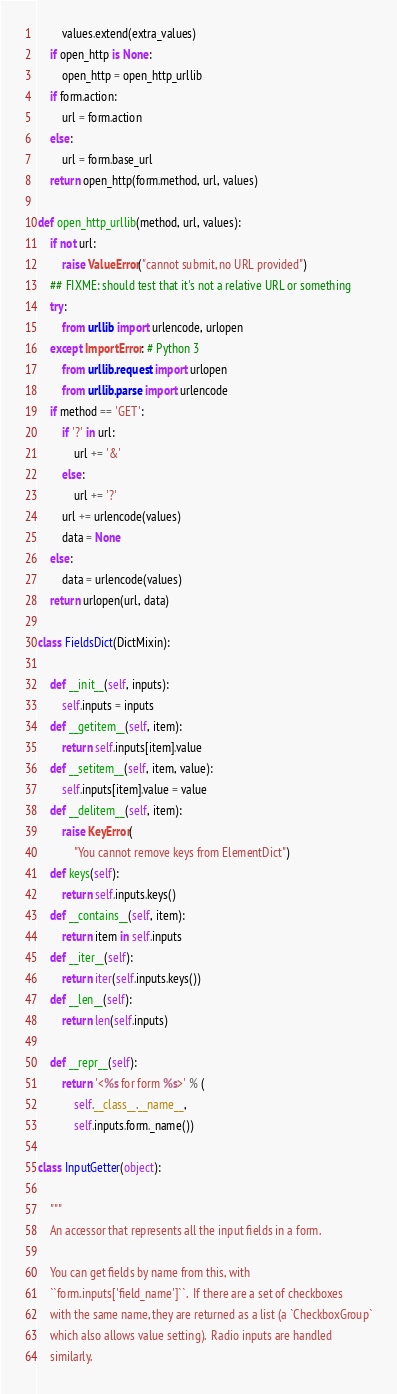Convert code to text. <code><loc_0><loc_0><loc_500><loc_500><_Python_>        values.extend(extra_values)
    if open_http is None:
        open_http = open_http_urllib
    if form.action:
        url = form.action
    else:
        url = form.base_url
    return open_http(form.method, url, values)

def open_http_urllib(method, url, values):
    if not url:
        raise ValueError("cannot submit, no URL provided")
    ## FIXME: should test that it's not a relative URL or something
    try:
        from urllib import urlencode, urlopen
    except ImportError: # Python 3
        from urllib.request import urlopen
        from urllib.parse import urlencode
    if method == 'GET':
        if '?' in url:
            url += '&'
        else:
            url += '?'
        url += urlencode(values)
        data = None
    else:
        data = urlencode(values)
    return urlopen(url, data)

class FieldsDict(DictMixin):

    def __init__(self, inputs):
        self.inputs = inputs
    def __getitem__(self, item):
        return self.inputs[item].value
    def __setitem__(self, item, value):
        self.inputs[item].value = value
    def __delitem__(self, item):
        raise KeyError(
            "You cannot remove keys from ElementDict")
    def keys(self):
        return self.inputs.keys()
    def __contains__(self, item):
        return item in self.inputs
    def __iter__(self):
        return iter(self.inputs.keys())
    def __len__(self):
        return len(self.inputs)

    def __repr__(self):
        return '<%s for form %s>' % (
            self.__class__.__name__,
            self.inputs.form._name())

class InputGetter(object):

    """
    An accessor that represents all the input fields in a form.

    You can get fields by name from this, with
    ``form.inputs['field_name']``.  If there are a set of checkboxes
    with the same name, they are returned as a list (a `CheckboxGroup`
    which also allows value setting).  Radio inputs are handled
    similarly.
</code> 